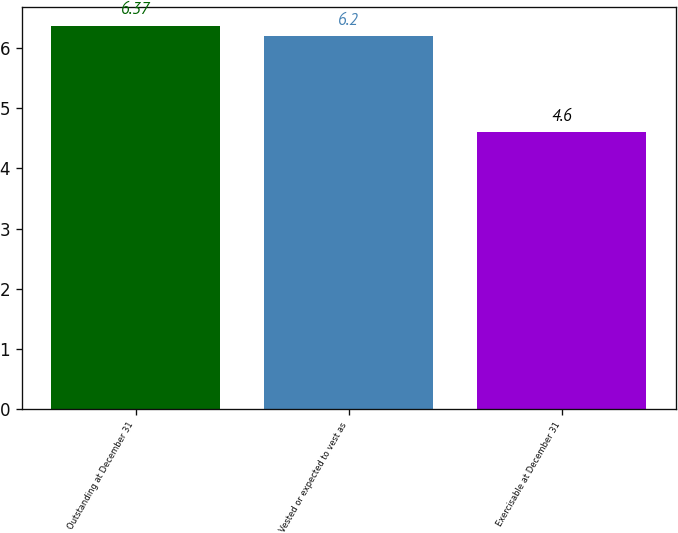<chart> <loc_0><loc_0><loc_500><loc_500><bar_chart><fcel>Outstanding at December 31<fcel>Vested or expected to vest as<fcel>Exercisable at December 31<nl><fcel>6.37<fcel>6.2<fcel>4.6<nl></chart> 